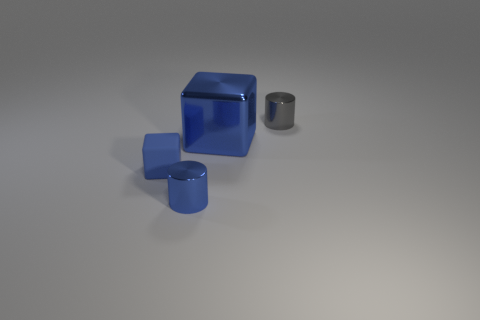How many blue blocks must be subtracted to get 1 blue blocks? 1 Add 4 purple things. How many objects exist? 8 Subtract all cyan metallic cylinders. Subtract all big blue shiny blocks. How many objects are left? 3 Add 1 tiny blue metal objects. How many tiny blue metal objects are left? 2 Add 4 red metal cylinders. How many red metal cylinders exist? 4 Subtract 0 yellow cylinders. How many objects are left? 4 